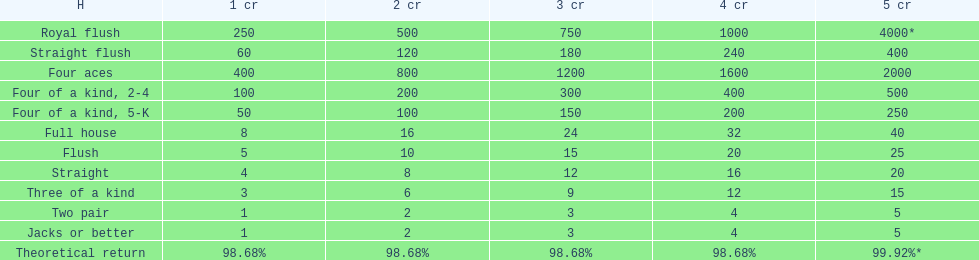What is the values in the 5 credits area? 4000*, 400, 2000, 500, 250, 40, 25, 20, 15, 5, 5. Which of these is for a four of a kind? 500, 250. What is the higher value? 500. What hand is this for Four of a kind, 2-4. 